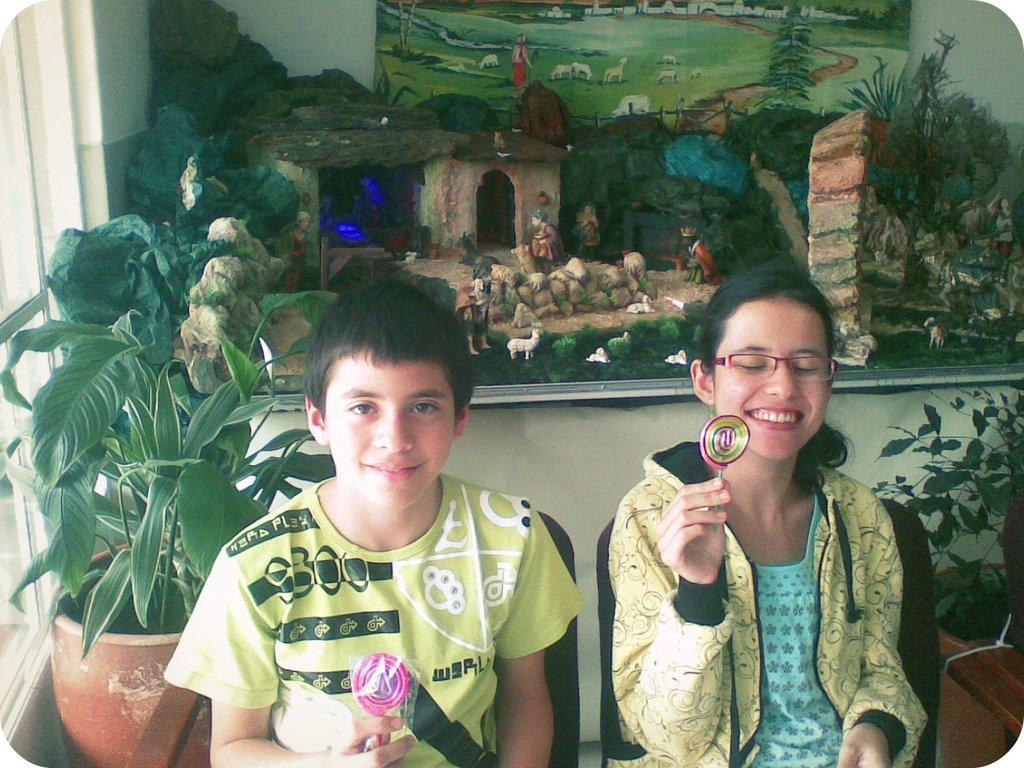How many people are sitting in the image? There are two people sitting on chairs in the image. What are the people holding in their hands? The people are holding something, but the specific object is not mentioned in the facts. What can be seen in the background of the image? There is a house, animals, and stones visible in the background of the image. What type of structure is present in the image? There is a wall and a window in the image. What color crayon is the person using to draw on the park bench in the image? There is no park bench or crayon present in the image. 